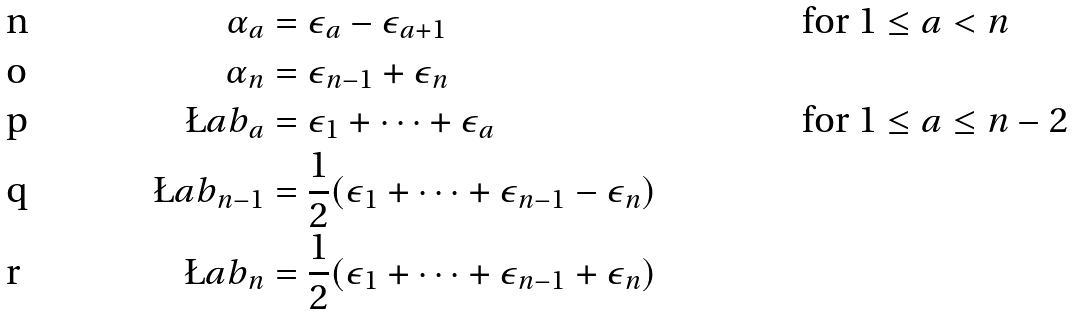Convert formula to latex. <formula><loc_0><loc_0><loc_500><loc_500>\alpha _ { a } & = \epsilon _ { a } - \epsilon _ { a + 1 } & & \text {for $1\leq a<n$} \\ \alpha _ { n } & = \epsilon _ { n - 1 } + \epsilon _ { n } & & \\ \L a b _ { a } & = \epsilon _ { 1 } + \cdots + \epsilon _ { a } & & \text {for $1\leq a\leq n-2$} \\ \L a b _ { n - 1 } & = \frac { 1 } { 2 } ( \epsilon _ { 1 } + \cdots + \epsilon _ { n - 1 } - \epsilon _ { n } ) & & \\ \L a b _ { n } & = \frac { 1 } { 2 } ( \epsilon _ { 1 } + \cdots + \epsilon _ { n - 1 } + \epsilon _ { n } ) & &</formula> 